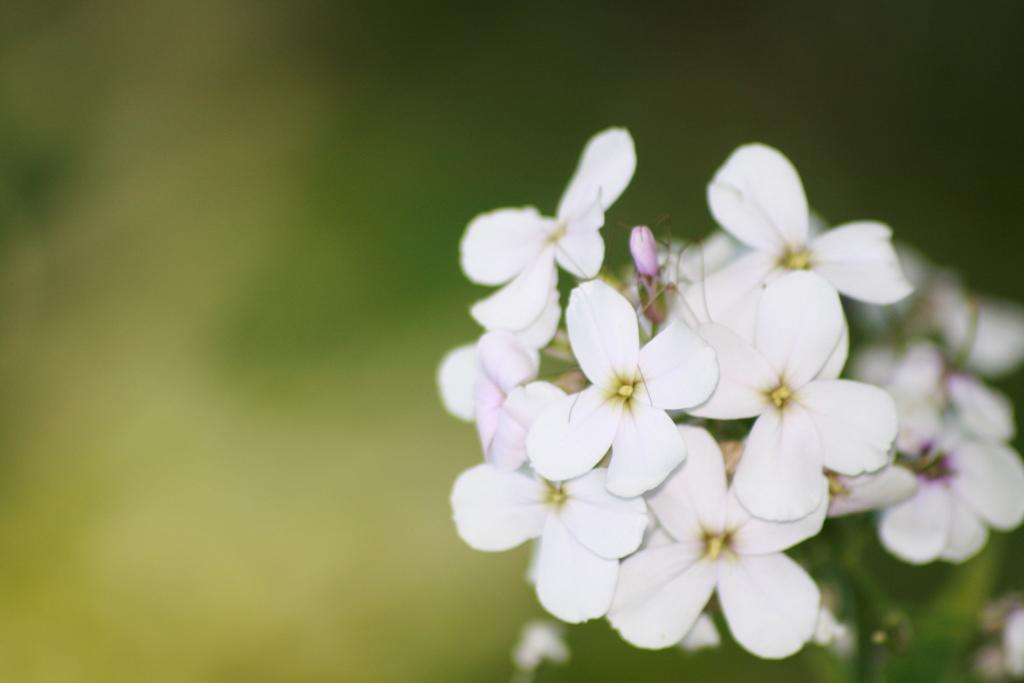What color are the flowers on the plant in the image? The flowers on the plant are white. Can you describe the quality of the image at the back? The image is blurry at the back. How many cows are visible in the image? There are no cows present in the image. What is in the pocket of the person in the image? There is no person or pocket visible in the image. 